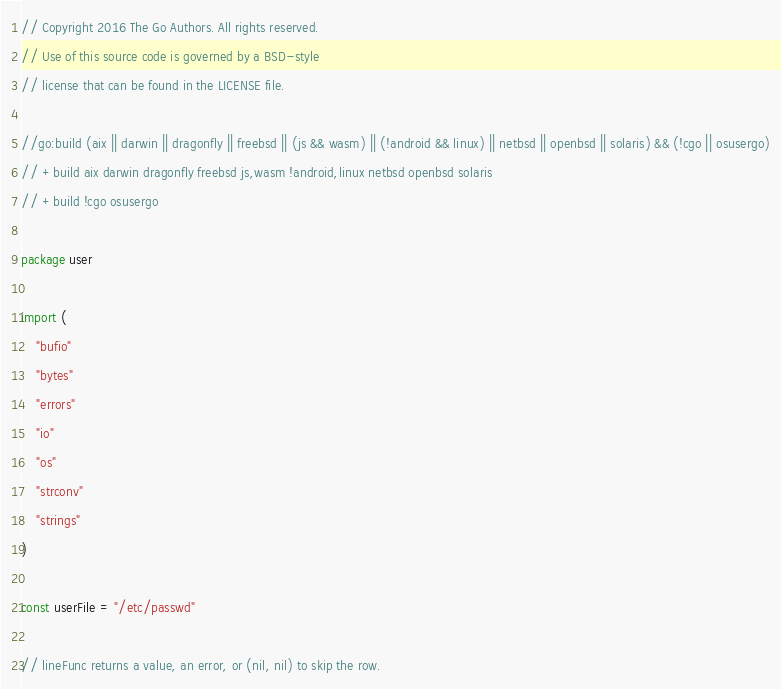<code> <loc_0><loc_0><loc_500><loc_500><_Go_>// Copyright 2016 The Go Authors. All rights reserved.
// Use of this source code is governed by a BSD-style
// license that can be found in the LICENSE file.

//go:build (aix || darwin || dragonfly || freebsd || (js && wasm) || (!android && linux) || netbsd || openbsd || solaris) && (!cgo || osusergo)
// +build aix darwin dragonfly freebsd js,wasm !android,linux netbsd openbsd solaris
// +build !cgo osusergo

package user

import (
	"bufio"
	"bytes"
	"errors"
	"io"
	"os"
	"strconv"
	"strings"
)

const userFile = "/etc/passwd"

// lineFunc returns a value, an error, or (nil, nil) to skip the row.</code> 